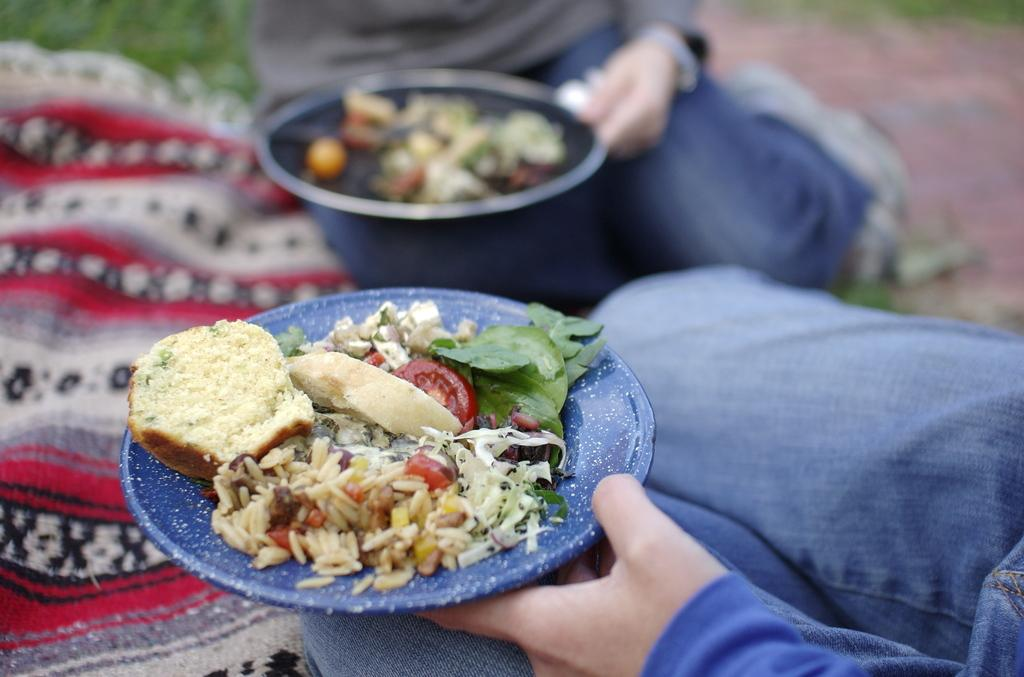How many people are present in the image? There are two people in the image. What are the two people doing in the image? The two people are holding food items on a plate. How are the food items being held by the people in the image? The food items are being held with their hands. What type of treatment is the grandmother receiving in the image? There is no grandmother or any indication of treatment present in the image. 